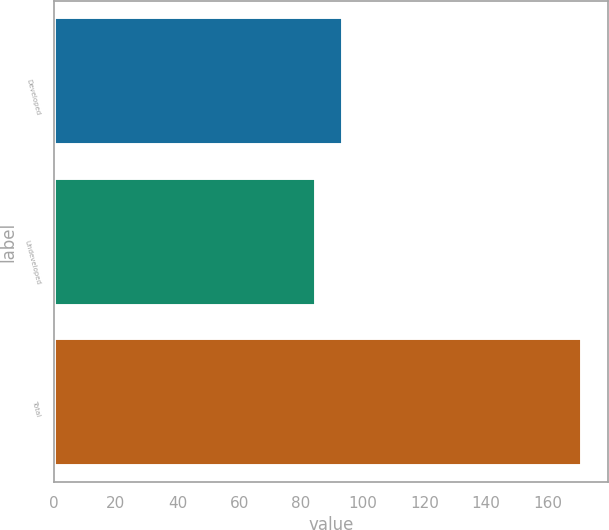Convert chart to OTSL. <chart><loc_0><loc_0><loc_500><loc_500><bar_chart><fcel>Developed<fcel>Undeveloped<fcel>Total<nl><fcel>93.6<fcel>85<fcel>171<nl></chart> 